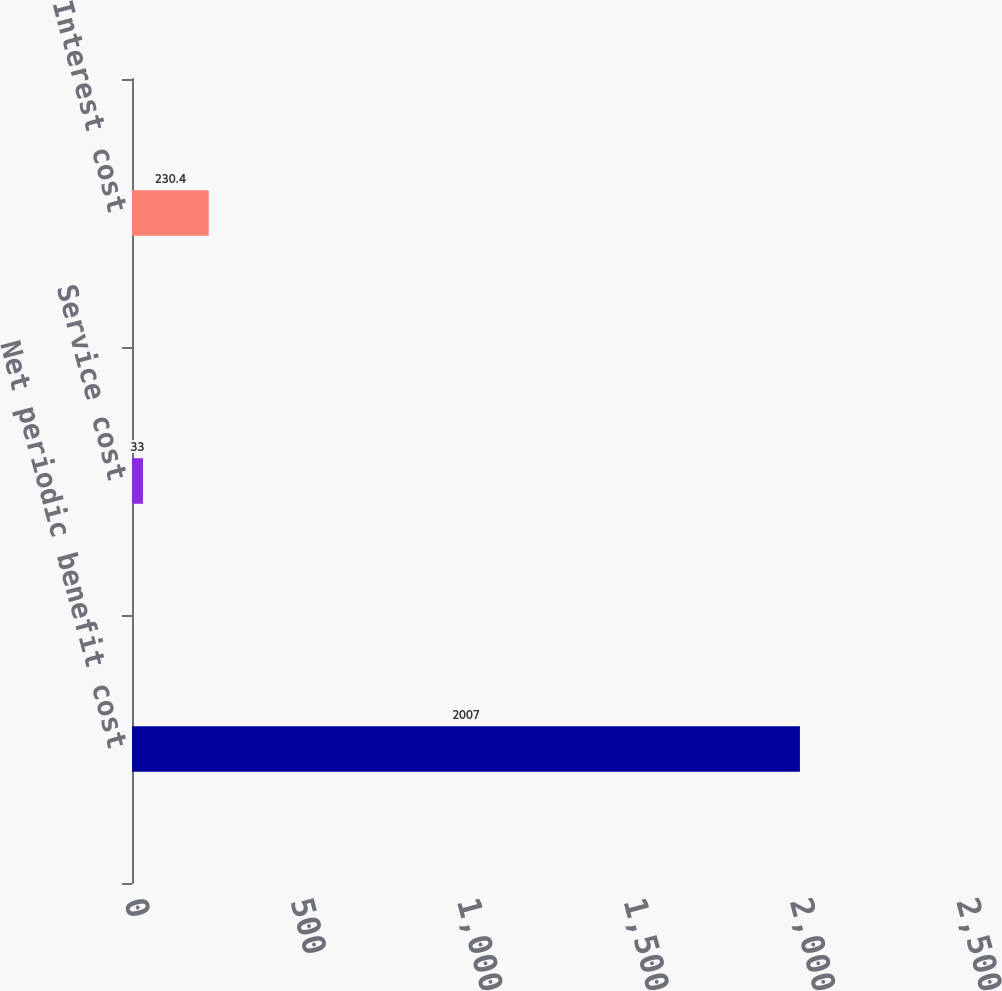<chart> <loc_0><loc_0><loc_500><loc_500><bar_chart><fcel>Net periodic benefit cost<fcel>Service cost<fcel>Interest cost<nl><fcel>2007<fcel>33<fcel>230.4<nl></chart> 